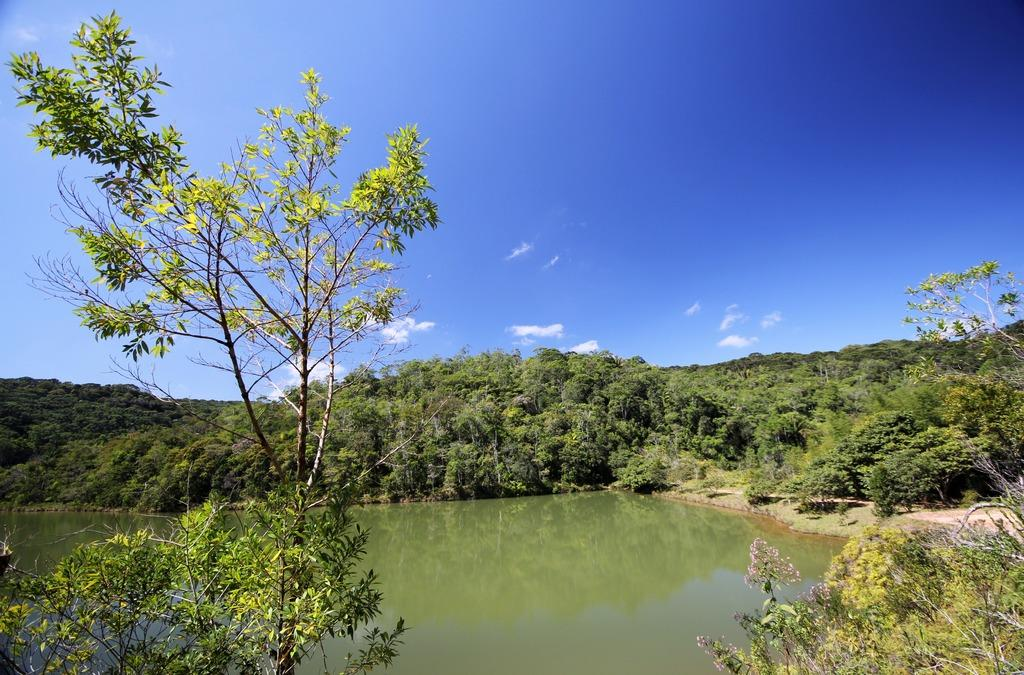What can be seen on the water's surface in the image? There are reflections of objects on the water in the image. What type of vegetation is visible in the image? There are plants and trees visible in the image. What is visible in the sky in the image? The sky is visible in the image, and clouds are present. Where are the dolls placed in the image? There are no dolls present in the image. What type of jewel can be seen in the image? There is no jewel present in the image. 